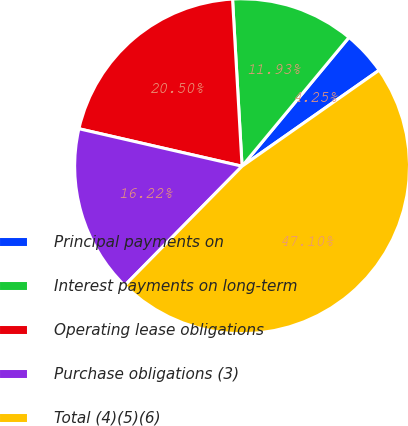Convert chart to OTSL. <chart><loc_0><loc_0><loc_500><loc_500><pie_chart><fcel>Principal payments on<fcel>Interest payments on long-term<fcel>Operating lease obligations<fcel>Purchase obligations (3)<fcel>Total (4)(5)(6)<nl><fcel>4.25%<fcel>11.93%<fcel>20.5%<fcel>16.22%<fcel>47.1%<nl></chart> 